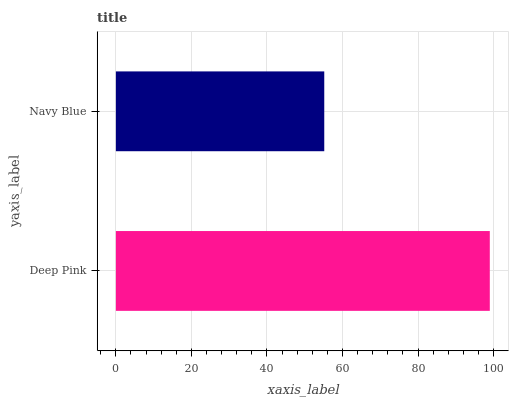Is Navy Blue the minimum?
Answer yes or no. Yes. Is Deep Pink the maximum?
Answer yes or no. Yes. Is Navy Blue the maximum?
Answer yes or no. No. Is Deep Pink greater than Navy Blue?
Answer yes or no. Yes. Is Navy Blue less than Deep Pink?
Answer yes or no. Yes. Is Navy Blue greater than Deep Pink?
Answer yes or no. No. Is Deep Pink less than Navy Blue?
Answer yes or no. No. Is Deep Pink the high median?
Answer yes or no. Yes. Is Navy Blue the low median?
Answer yes or no. Yes. Is Navy Blue the high median?
Answer yes or no. No. Is Deep Pink the low median?
Answer yes or no. No. 